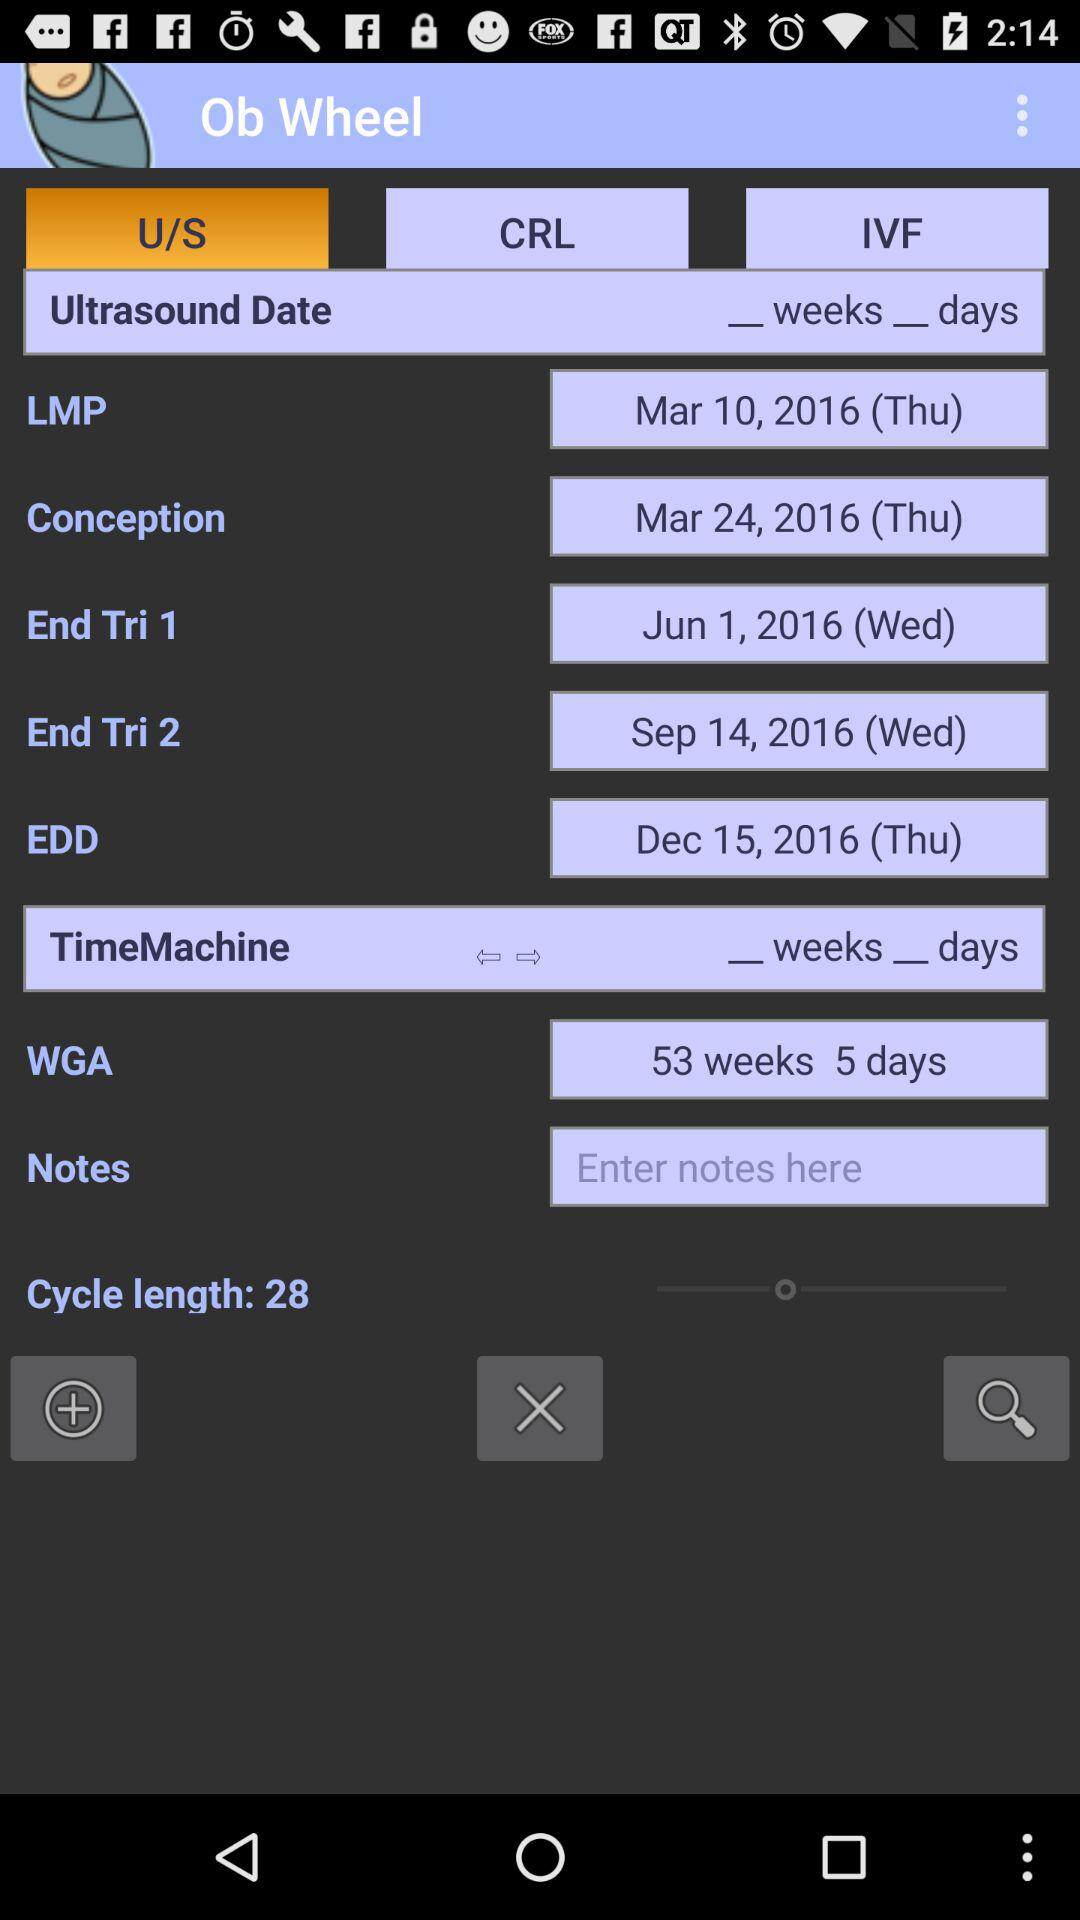How many weeks between the End Tri 1 and End Tri 2 dates?
Answer the question using a single word or phrase. 13 weeks 